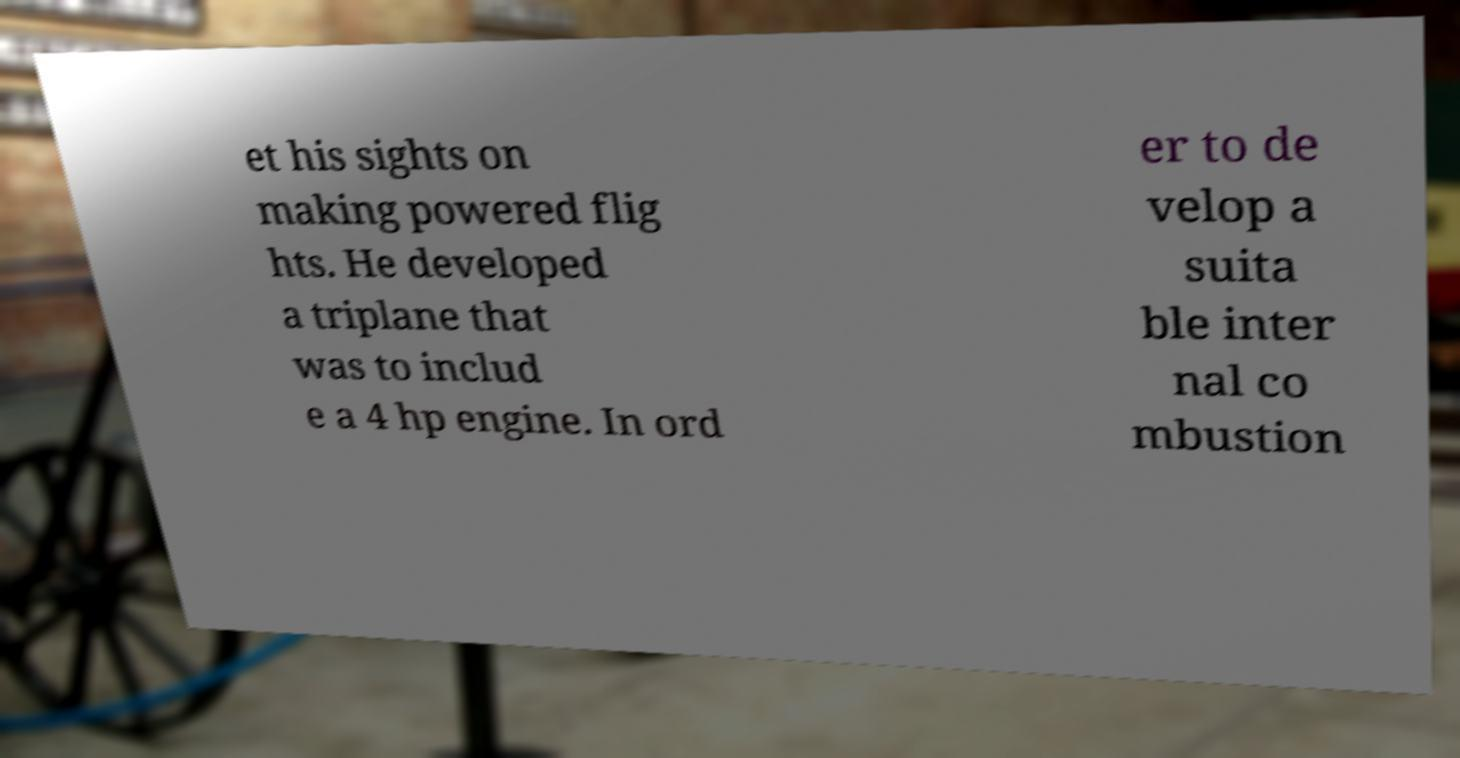I need the written content from this picture converted into text. Can you do that? et his sights on making powered flig hts. He developed a triplane that was to includ e a 4 hp engine. In ord er to de velop a suita ble inter nal co mbustion 